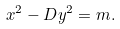Convert formula to latex. <formula><loc_0><loc_0><loc_500><loc_500>x ^ { 2 } - D y ^ { 2 } = m .</formula> 